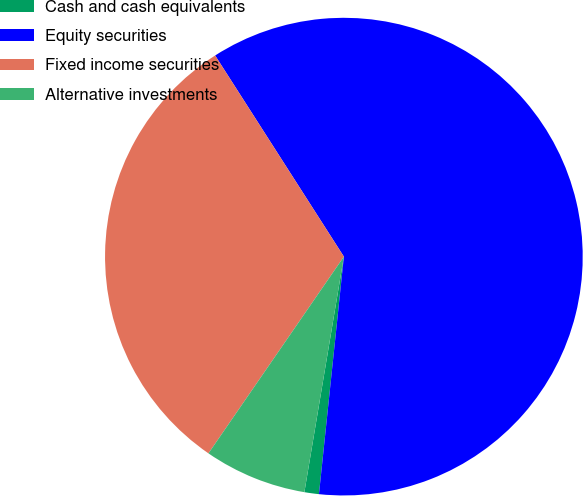Convert chart. <chart><loc_0><loc_0><loc_500><loc_500><pie_chart><fcel>Cash and cash equivalents<fcel>Equity securities<fcel>Fixed income securities<fcel>Alternative investments<nl><fcel>0.98%<fcel>60.72%<fcel>31.34%<fcel>6.95%<nl></chart> 